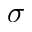Convert formula to latex. <formula><loc_0><loc_0><loc_500><loc_500>\sigma</formula> 